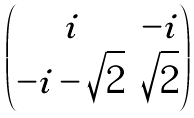<formula> <loc_0><loc_0><loc_500><loc_500>\begin{pmatrix} i & - i \\ - i - \sqrt { 2 } & \sqrt { 2 } \end{pmatrix}</formula> 